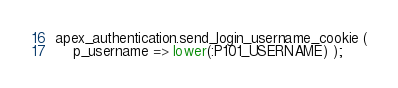<code> <loc_0><loc_0><loc_500><loc_500><_SQL_>apex_authentication.send_login_username_cookie (
    p_username => lower(:P101_USERNAME) );</code> 